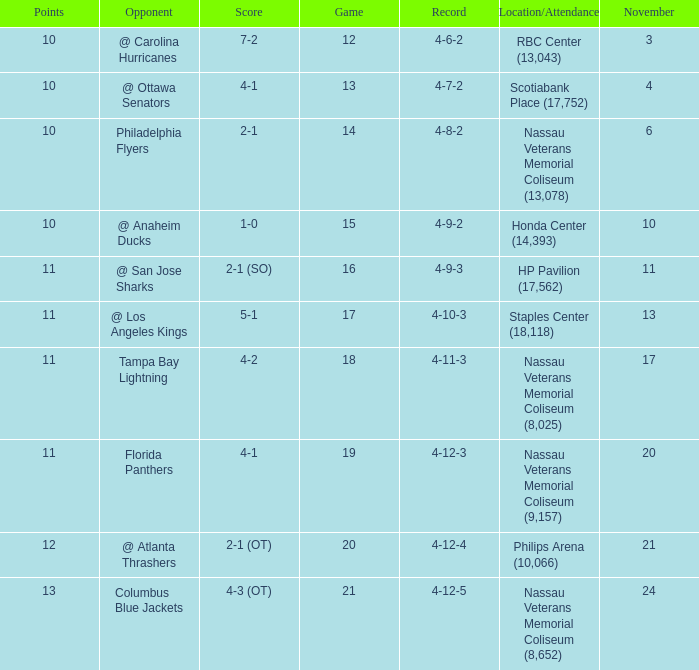What is the least amount of points? 10.0. 